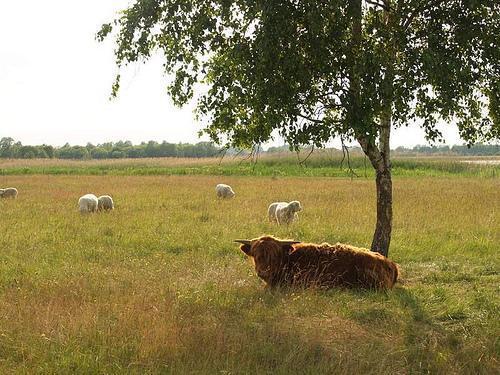How many cows are there?
Give a very brief answer. 1. How many sheep are there?
Give a very brief answer. 5. How many total animals are in the picture?
Give a very brief answer. 6. 